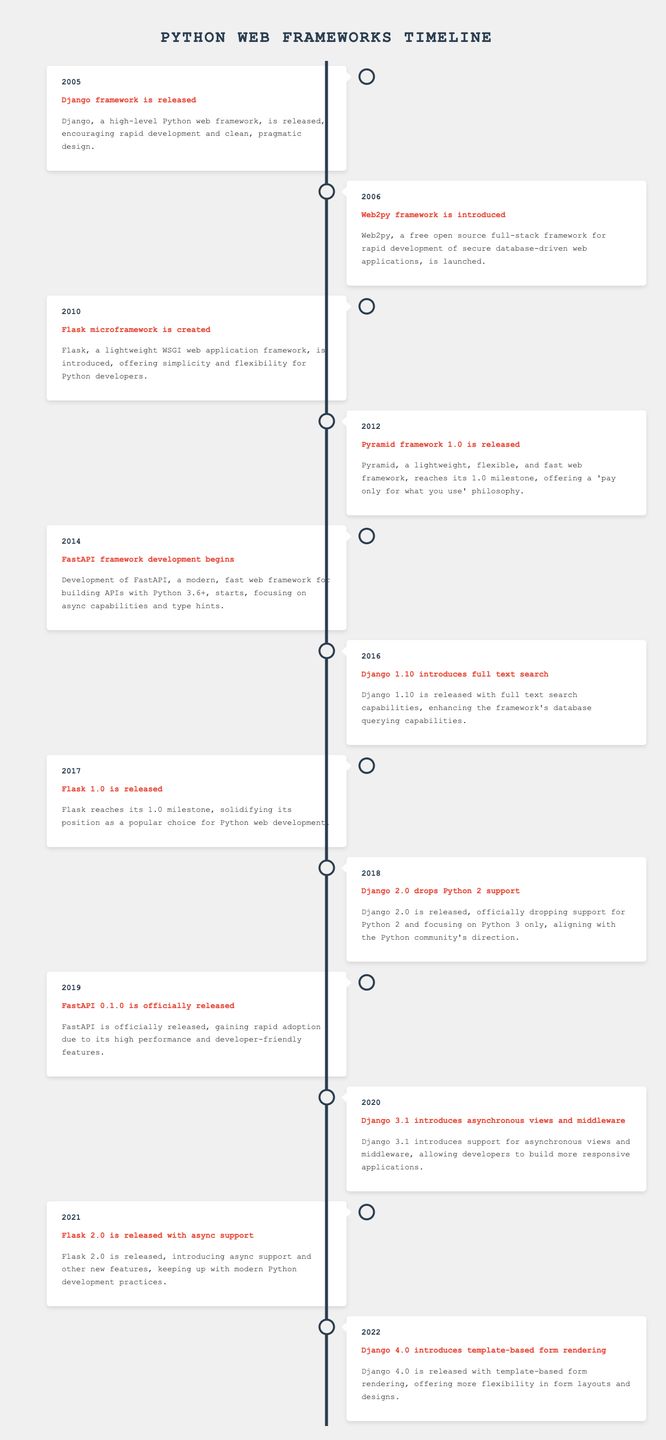What event marks the introduction of Flask? Flask, a lightweight WSGI web application framework, is introduced in 2010, which can be easily located in the table as the event listed under the year 2010.
Answer: Flask microframework is created In what year did Django drop support for Python 2? According to the table, Django officially dropped support for Python 2 in 2018, which is identified under the event concerning Django 2.0.
Answer: 2018 How many years are there between the release of Django 1.10 and Flask 1.0? From the table, Django 1.10 was released in 2016 and Flask 1.0 in 2017. The difference in years is calculated as 2017 - 2016 = 1 year.
Answer: 1 Was FastAPI officially released before Flask 2.0? The table shows FastAPI 0.1.0 was officially released in 2019, while Flask 2.0 was released in 2021. Since 2019 is before 2021, the statement is true.
Answer: Yes What is the sequence of framework releases from 2005 to 2014? To arrive at the answer, look at the years from the table: Django was released in 2005, followed by Web2py in 2006, Flask in 2010, and FastAPI development starting in 2014. Therefore, the sequence is: Django, Web2py, Flask, FastAPI.
Answer: Django, Web2py, Flask, FastAPI How many events occurred in the year 2020 or later? Reviewing the table, events from 2020 and beyond are: Django 3.1 introduces asynchronous views (2020), Flask 2.0 is released with async support (2021), and Django 4.0 introduces template-based form rendering (2022). This totals to 3 events.
Answer: 3 What significant change was introduced by Django 3.1? The table states that Django 3.1 introduced support for asynchronous views and middleware, leading to more responsive applications, which is a notable change for the framework.
Answer: Asynchronous views and middleware Can you list all frameworks introduced before 2012? From the table, the frameworks introduced before 2012 include Django in 2005, Web2py in 2006, and Flask in 2010. Using the events listed helps to compile this information accurately.
Answer: Django, Web2py, Flask 